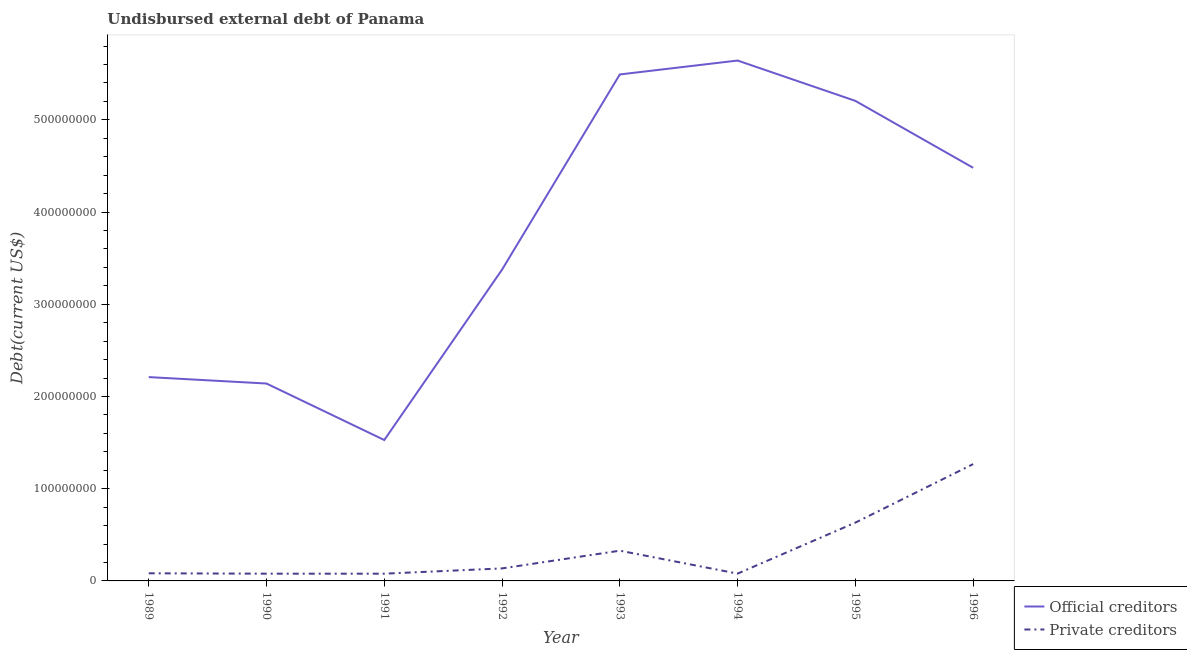What is the undisbursed external debt of private creditors in 1995?
Ensure brevity in your answer.  6.32e+07. Across all years, what is the maximum undisbursed external debt of official creditors?
Offer a terse response. 5.64e+08. Across all years, what is the minimum undisbursed external debt of private creditors?
Provide a short and direct response. 7.85e+06. In which year was the undisbursed external debt of official creditors minimum?
Your answer should be very brief. 1991. What is the total undisbursed external debt of official creditors in the graph?
Give a very brief answer. 3.01e+09. What is the difference between the undisbursed external debt of official creditors in 1992 and that in 1996?
Keep it short and to the point. -1.10e+08. What is the difference between the undisbursed external debt of official creditors in 1996 and the undisbursed external debt of private creditors in 1992?
Your answer should be very brief. 4.34e+08. What is the average undisbursed external debt of official creditors per year?
Keep it short and to the point. 3.76e+08. In the year 1990, what is the difference between the undisbursed external debt of official creditors and undisbursed external debt of private creditors?
Your answer should be very brief. 2.06e+08. In how many years, is the undisbursed external debt of official creditors greater than 360000000 US$?
Offer a terse response. 4. What is the ratio of the undisbursed external debt of private creditors in 1993 to that in 1995?
Make the answer very short. 0.52. Is the undisbursed external debt of private creditors in 1992 less than that in 1994?
Make the answer very short. No. What is the difference between the highest and the second highest undisbursed external debt of official creditors?
Provide a short and direct response. 1.51e+07. What is the difference between the highest and the lowest undisbursed external debt of private creditors?
Your answer should be compact. 1.19e+08. Is the sum of the undisbursed external debt of official creditors in 1989 and 1991 greater than the maximum undisbursed external debt of private creditors across all years?
Your answer should be compact. Yes. Is the undisbursed external debt of private creditors strictly less than the undisbursed external debt of official creditors over the years?
Offer a very short reply. Yes. What is the difference between two consecutive major ticks on the Y-axis?
Your answer should be compact. 1.00e+08. Does the graph contain any zero values?
Offer a very short reply. No. Does the graph contain grids?
Provide a succinct answer. No. How are the legend labels stacked?
Provide a short and direct response. Vertical. What is the title of the graph?
Provide a short and direct response. Undisbursed external debt of Panama. Does "Under five" appear as one of the legend labels in the graph?
Provide a short and direct response. No. What is the label or title of the X-axis?
Ensure brevity in your answer.  Year. What is the label or title of the Y-axis?
Your response must be concise. Debt(current US$). What is the Debt(current US$) of Official creditors in 1989?
Ensure brevity in your answer.  2.21e+08. What is the Debt(current US$) of Private creditors in 1989?
Ensure brevity in your answer.  8.26e+06. What is the Debt(current US$) in Official creditors in 1990?
Provide a short and direct response. 2.14e+08. What is the Debt(current US$) of Private creditors in 1990?
Ensure brevity in your answer.  7.85e+06. What is the Debt(current US$) in Official creditors in 1991?
Keep it short and to the point. 1.53e+08. What is the Debt(current US$) in Private creditors in 1991?
Provide a short and direct response. 7.85e+06. What is the Debt(current US$) in Official creditors in 1992?
Make the answer very short. 3.38e+08. What is the Debt(current US$) in Private creditors in 1992?
Offer a very short reply. 1.36e+07. What is the Debt(current US$) in Official creditors in 1993?
Offer a very short reply. 5.49e+08. What is the Debt(current US$) of Private creditors in 1993?
Your answer should be very brief. 3.28e+07. What is the Debt(current US$) in Official creditors in 1994?
Your answer should be compact. 5.64e+08. What is the Debt(current US$) of Private creditors in 1994?
Make the answer very short. 7.92e+06. What is the Debt(current US$) in Official creditors in 1995?
Ensure brevity in your answer.  5.21e+08. What is the Debt(current US$) in Private creditors in 1995?
Give a very brief answer. 6.32e+07. What is the Debt(current US$) in Official creditors in 1996?
Give a very brief answer. 4.48e+08. What is the Debt(current US$) in Private creditors in 1996?
Your answer should be compact. 1.27e+08. Across all years, what is the maximum Debt(current US$) of Official creditors?
Ensure brevity in your answer.  5.64e+08. Across all years, what is the maximum Debt(current US$) in Private creditors?
Provide a succinct answer. 1.27e+08. Across all years, what is the minimum Debt(current US$) of Official creditors?
Provide a short and direct response. 1.53e+08. Across all years, what is the minimum Debt(current US$) of Private creditors?
Make the answer very short. 7.85e+06. What is the total Debt(current US$) in Official creditors in the graph?
Provide a succinct answer. 3.01e+09. What is the total Debt(current US$) in Private creditors in the graph?
Make the answer very short. 2.68e+08. What is the difference between the Debt(current US$) of Official creditors in 1989 and that in 1990?
Ensure brevity in your answer.  6.97e+06. What is the difference between the Debt(current US$) in Private creditors in 1989 and that in 1990?
Offer a very short reply. 4.11e+05. What is the difference between the Debt(current US$) of Official creditors in 1989 and that in 1991?
Your answer should be compact. 6.82e+07. What is the difference between the Debt(current US$) in Private creditors in 1989 and that in 1991?
Keep it short and to the point. 4.18e+05. What is the difference between the Debt(current US$) in Official creditors in 1989 and that in 1992?
Your answer should be very brief. -1.17e+08. What is the difference between the Debt(current US$) in Private creditors in 1989 and that in 1992?
Keep it short and to the point. -5.31e+06. What is the difference between the Debt(current US$) in Official creditors in 1989 and that in 1993?
Make the answer very short. -3.28e+08. What is the difference between the Debt(current US$) of Private creditors in 1989 and that in 1993?
Keep it short and to the point. -2.45e+07. What is the difference between the Debt(current US$) of Official creditors in 1989 and that in 1994?
Your response must be concise. -3.43e+08. What is the difference between the Debt(current US$) of Private creditors in 1989 and that in 1994?
Offer a terse response. 3.43e+05. What is the difference between the Debt(current US$) of Official creditors in 1989 and that in 1995?
Make the answer very short. -3.00e+08. What is the difference between the Debt(current US$) in Private creditors in 1989 and that in 1995?
Ensure brevity in your answer.  -5.50e+07. What is the difference between the Debt(current US$) of Official creditors in 1989 and that in 1996?
Your answer should be very brief. -2.27e+08. What is the difference between the Debt(current US$) in Private creditors in 1989 and that in 1996?
Your answer should be compact. -1.18e+08. What is the difference between the Debt(current US$) of Official creditors in 1990 and that in 1991?
Give a very brief answer. 6.13e+07. What is the difference between the Debt(current US$) in Private creditors in 1990 and that in 1991?
Your answer should be very brief. 7000. What is the difference between the Debt(current US$) of Official creditors in 1990 and that in 1992?
Your answer should be compact. -1.23e+08. What is the difference between the Debt(current US$) of Private creditors in 1990 and that in 1992?
Your response must be concise. -5.72e+06. What is the difference between the Debt(current US$) of Official creditors in 1990 and that in 1993?
Ensure brevity in your answer.  -3.35e+08. What is the difference between the Debt(current US$) in Private creditors in 1990 and that in 1993?
Keep it short and to the point. -2.49e+07. What is the difference between the Debt(current US$) in Official creditors in 1990 and that in 1994?
Provide a short and direct response. -3.50e+08. What is the difference between the Debt(current US$) of Private creditors in 1990 and that in 1994?
Offer a terse response. -6.80e+04. What is the difference between the Debt(current US$) in Official creditors in 1990 and that in 1995?
Your response must be concise. -3.06e+08. What is the difference between the Debt(current US$) of Private creditors in 1990 and that in 1995?
Provide a short and direct response. -5.54e+07. What is the difference between the Debt(current US$) of Official creditors in 1990 and that in 1996?
Ensure brevity in your answer.  -2.34e+08. What is the difference between the Debt(current US$) of Private creditors in 1990 and that in 1996?
Ensure brevity in your answer.  -1.19e+08. What is the difference between the Debt(current US$) of Official creditors in 1991 and that in 1992?
Offer a terse response. -1.85e+08. What is the difference between the Debt(current US$) in Private creditors in 1991 and that in 1992?
Give a very brief answer. -5.73e+06. What is the difference between the Debt(current US$) in Official creditors in 1991 and that in 1993?
Give a very brief answer. -3.96e+08. What is the difference between the Debt(current US$) of Private creditors in 1991 and that in 1993?
Your response must be concise. -2.49e+07. What is the difference between the Debt(current US$) of Official creditors in 1991 and that in 1994?
Make the answer very short. -4.12e+08. What is the difference between the Debt(current US$) of Private creditors in 1991 and that in 1994?
Offer a terse response. -7.50e+04. What is the difference between the Debt(current US$) in Official creditors in 1991 and that in 1995?
Make the answer very short. -3.68e+08. What is the difference between the Debt(current US$) of Private creditors in 1991 and that in 1995?
Offer a terse response. -5.54e+07. What is the difference between the Debt(current US$) of Official creditors in 1991 and that in 1996?
Your answer should be compact. -2.95e+08. What is the difference between the Debt(current US$) of Private creditors in 1991 and that in 1996?
Provide a short and direct response. -1.19e+08. What is the difference between the Debt(current US$) in Official creditors in 1992 and that in 1993?
Your response must be concise. -2.12e+08. What is the difference between the Debt(current US$) in Private creditors in 1992 and that in 1993?
Provide a succinct answer. -1.92e+07. What is the difference between the Debt(current US$) in Official creditors in 1992 and that in 1994?
Your answer should be very brief. -2.27e+08. What is the difference between the Debt(current US$) in Private creditors in 1992 and that in 1994?
Your answer should be compact. 5.66e+06. What is the difference between the Debt(current US$) in Official creditors in 1992 and that in 1995?
Your response must be concise. -1.83e+08. What is the difference between the Debt(current US$) of Private creditors in 1992 and that in 1995?
Make the answer very short. -4.96e+07. What is the difference between the Debt(current US$) of Official creditors in 1992 and that in 1996?
Keep it short and to the point. -1.10e+08. What is the difference between the Debt(current US$) in Private creditors in 1992 and that in 1996?
Offer a very short reply. -1.13e+08. What is the difference between the Debt(current US$) of Official creditors in 1993 and that in 1994?
Keep it short and to the point. -1.51e+07. What is the difference between the Debt(current US$) in Private creditors in 1993 and that in 1994?
Your answer should be very brief. 2.49e+07. What is the difference between the Debt(current US$) in Official creditors in 1993 and that in 1995?
Provide a short and direct response. 2.87e+07. What is the difference between the Debt(current US$) in Private creditors in 1993 and that in 1995?
Keep it short and to the point. -3.04e+07. What is the difference between the Debt(current US$) of Official creditors in 1993 and that in 1996?
Your response must be concise. 1.01e+08. What is the difference between the Debt(current US$) of Private creditors in 1993 and that in 1996?
Provide a short and direct response. -9.39e+07. What is the difference between the Debt(current US$) in Official creditors in 1994 and that in 1995?
Provide a short and direct response. 4.38e+07. What is the difference between the Debt(current US$) in Private creditors in 1994 and that in 1995?
Offer a very short reply. -5.53e+07. What is the difference between the Debt(current US$) of Official creditors in 1994 and that in 1996?
Ensure brevity in your answer.  1.16e+08. What is the difference between the Debt(current US$) of Private creditors in 1994 and that in 1996?
Give a very brief answer. -1.19e+08. What is the difference between the Debt(current US$) of Official creditors in 1995 and that in 1996?
Provide a short and direct response. 7.26e+07. What is the difference between the Debt(current US$) in Private creditors in 1995 and that in 1996?
Your response must be concise. -6.35e+07. What is the difference between the Debt(current US$) in Official creditors in 1989 and the Debt(current US$) in Private creditors in 1990?
Keep it short and to the point. 2.13e+08. What is the difference between the Debt(current US$) of Official creditors in 1989 and the Debt(current US$) of Private creditors in 1991?
Keep it short and to the point. 2.13e+08. What is the difference between the Debt(current US$) of Official creditors in 1989 and the Debt(current US$) of Private creditors in 1992?
Your answer should be very brief. 2.07e+08. What is the difference between the Debt(current US$) in Official creditors in 1989 and the Debt(current US$) in Private creditors in 1993?
Offer a very short reply. 1.88e+08. What is the difference between the Debt(current US$) in Official creditors in 1989 and the Debt(current US$) in Private creditors in 1994?
Offer a very short reply. 2.13e+08. What is the difference between the Debt(current US$) of Official creditors in 1989 and the Debt(current US$) of Private creditors in 1995?
Your answer should be very brief. 1.58e+08. What is the difference between the Debt(current US$) in Official creditors in 1989 and the Debt(current US$) in Private creditors in 1996?
Your response must be concise. 9.43e+07. What is the difference between the Debt(current US$) of Official creditors in 1990 and the Debt(current US$) of Private creditors in 1991?
Keep it short and to the point. 2.06e+08. What is the difference between the Debt(current US$) of Official creditors in 1990 and the Debt(current US$) of Private creditors in 1992?
Provide a succinct answer. 2.00e+08. What is the difference between the Debt(current US$) of Official creditors in 1990 and the Debt(current US$) of Private creditors in 1993?
Ensure brevity in your answer.  1.81e+08. What is the difference between the Debt(current US$) in Official creditors in 1990 and the Debt(current US$) in Private creditors in 1994?
Give a very brief answer. 2.06e+08. What is the difference between the Debt(current US$) of Official creditors in 1990 and the Debt(current US$) of Private creditors in 1995?
Give a very brief answer. 1.51e+08. What is the difference between the Debt(current US$) in Official creditors in 1990 and the Debt(current US$) in Private creditors in 1996?
Offer a terse response. 8.74e+07. What is the difference between the Debt(current US$) of Official creditors in 1991 and the Debt(current US$) of Private creditors in 1992?
Provide a short and direct response. 1.39e+08. What is the difference between the Debt(current US$) of Official creditors in 1991 and the Debt(current US$) of Private creditors in 1993?
Keep it short and to the point. 1.20e+08. What is the difference between the Debt(current US$) of Official creditors in 1991 and the Debt(current US$) of Private creditors in 1994?
Provide a short and direct response. 1.45e+08. What is the difference between the Debt(current US$) of Official creditors in 1991 and the Debt(current US$) of Private creditors in 1995?
Make the answer very short. 8.96e+07. What is the difference between the Debt(current US$) in Official creditors in 1991 and the Debt(current US$) in Private creditors in 1996?
Ensure brevity in your answer.  2.61e+07. What is the difference between the Debt(current US$) of Official creditors in 1992 and the Debt(current US$) of Private creditors in 1993?
Provide a short and direct response. 3.05e+08. What is the difference between the Debt(current US$) of Official creditors in 1992 and the Debt(current US$) of Private creditors in 1994?
Your answer should be compact. 3.30e+08. What is the difference between the Debt(current US$) of Official creditors in 1992 and the Debt(current US$) of Private creditors in 1995?
Ensure brevity in your answer.  2.74e+08. What is the difference between the Debt(current US$) in Official creditors in 1992 and the Debt(current US$) in Private creditors in 1996?
Provide a succinct answer. 2.11e+08. What is the difference between the Debt(current US$) of Official creditors in 1993 and the Debt(current US$) of Private creditors in 1994?
Your answer should be very brief. 5.41e+08. What is the difference between the Debt(current US$) in Official creditors in 1993 and the Debt(current US$) in Private creditors in 1995?
Make the answer very short. 4.86e+08. What is the difference between the Debt(current US$) in Official creditors in 1993 and the Debt(current US$) in Private creditors in 1996?
Your response must be concise. 4.23e+08. What is the difference between the Debt(current US$) in Official creditors in 1994 and the Debt(current US$) in Private creditors in 1995?
Ensure brevity in your answer.  5.01e+08. What is the difference between the Debt(current US$) in Official creditors in 1994 and the Debt(current US$) in Private creditors in 1996?
Offer a very short reply. 4.38e+08. What is the difference between the Debt(current US$) in Official creditors in 1995 and the Debt(current US$) in Private creditors in 1996?
Offer a terse response. 3.94e+08. What is the average Debt(current US$) of Official creditors per year?
Make the answer very short. 3.76e+08. What is the average Debt(current US$) in Private creditors per year?
Your response must be concise. 3.35e+07. In the year 1989, what is the difference between the Debt(current US$) of Official creditors and Debt(current US$) of Private creditors?
Offer a terse response. 2.13e+08. In the year 1990, what is the difference between the Debt(current US$) in Official creditors and Debt(current US$) in Private creditors?
Offer a very short reply. 2.06e+08. In the year 1991, what is the difference between the Debt(current US$) of Official creditors and Debt(current US$) of Private creditors?
Provide a succinct answer. 1.45e+08. In the year 1992, what is the difference between the Debt(current US$) of Official creditors and Debt(current US$) of Private creditors?
Ensure brevity in your answer.  3.24e+08. In the year 1993, what is the difference between the Debt(current US$) in Official creditors and Debt(current US$) in Private creditors?
Your answer should be very brief. 5.16e+08. In the year 1994, what is the difference between the Debt(current US$) of Official creditors and Debt(current US$) of Private creditors?
Provide a succinct answer. 5.56e+08. In the year 1995, what is the difference between the Debt(current US$) of Official creditors and Debt(current US$) of Private creditors?
Your answer should be compact. 4.57e+08. In the year 1996, what is the difference between the Debt(current US$) in Official creditors and Debt(current US$) in Private creditors?
Your answer should be very brief. 3.21e+08. What is the ratio of the Debt(current US$) of Official creditors in 1989 to that in 1990?
Your answer should be very brief. 1.03. What is the ratio of the Debt(current US$) in Private creditors in 1989 to that in 1990?
Your answer should be compact. 1.05. What is the ratio of the Debt(current US$) of Official creditors in 1989 to that in 1991?
Give a very brief answer. 1.45. What is the ratio of the Debt(current US$) in Private creditors in 1989 to that in 1991?
Make the answer very short. 1.05. What is the ratio of the Debt(current US$) of Official creditors in 1989 to that in 1992?
Keep it short and to the point. 0.65. What is the ratio of the Debt(current US$) of Private creditors in 1989 to that in 1992?
Keep it short and to the point. 0.61. What is the ratio of the Debt(current US$) of Official creditors in 1989 to that in 1993?
Offer a terse response. 0.4. What is the ratio of the Debt(current US$) of Private creditors in 1989 to that in 1993?
Keep it short and to the point. 0.25. What is the ratio of the Debt(current US$) of Official creditors in 1989 to that in 1994?
Give a very brief answer. 0.39. What is the ratio of the Debt(current US$) in Private creditors in 1989 to that in 1994?
Your answer should be compact. 1.04. What is the ratio of the Debt(current US$) of Official creditors in 1989 to that in 1995?
Offer a terse response. 0.42. What is the ratio of the Debt(current US$) of Private creditors in 1989 to that in 1995?
Offer a very short reply. 0.13. What is the ratio of the Debt(current US$) of Official creditors in 1989 to that in 1996?
Give a very brief answer. 0.49. What is the ratio of the Debt(current US$) in Private creditors in 1989 to that in 1996?
Your answer should be very brief. 0.07. What is the ratio of the Debt(current US$) in Official creditors in 1990 to that in 1991?
Your answer should be very brief. 1.4. What is the ratio of the Debt(current US$) of Official creditors in 1990 to that in 1992?
Offer a terse response. 0.63. What is the ratio of the Debt(current US$) of Private creditors in 1990 to that in 1992?
Ensure brevity in your answer.  0.58. What is the ratio of the Debt(current US$) of Official creditors in 1990 to that in 1993?
Make the answer very short. 0.39. What is the ratio of the Debt(current US$) of Private creditors in 1990 to that in 1993?
Ensure brevity in your answer.  0.24. What is the ratio of the Debt(current US$) in Official creditors in 1990 to that in 1994?
Make the answer very short. 0.38. What is the ratio of the Debt(current US$) of Official creditors in 1990 to that in 1995?
Give a very brief answer. 0.41. What is the ratio of the Debt(current US$) of Private creditors in 1990 to that in 1995?
Your answer should be very brief. 0.12. What is the ratio of the Debt(current US$) of Official creditors in 1990 to that in 1996?
Give a very brief answer. 0.48. What is the ratio of the Debt(current US$) of Private creditors in 1990 to that in 1996?
Give a very brief answer. 0.06. What is the ratio of the Debt(current US$) of Official creditors in 1991 to that in 1992?
Provide a succinct answer. 0.45. What is the ratio of the Debt(current US$) in Private creditors in 1991 to that in 1992?
Provide a succinct answer. 0.58. What is the ratio of the Debt(current US$) of Official creditors in 1991 to that in 1993?
Your response must be concise. 0.28. What is the ratio of the Debt(current US$) in Private creditors in 1991 to that in 1993?
Give a very brief answer. 0.24. What is the ratio of the Debt(current US$) of Official creditors in 1991 to that in 1994?
Give a very brief answer. 0.27. What is the ratio of the Debt(current US$) in Official creditors in 1991 to that in 1995?
Offer a terse response. 0.29. What is the ratio of the Debt(current US$) in Private creditors in 1991 to that in 1995?
Your answer should be compact. 0.12. What is the ratio of the Debt(current US$) in Official creditors in 1991 to that in 1996?
Keep it short and to the point. 0.34. What is the ratio of the Debt(current US$) of Private creditors in 1991 to that in 1996?
Provide a short and direct response. 0.06. What is the ratio of the Debt(current US$) in Official creditors in 1992 to that in 1993?
Ensure brevity in your answer.  0.61. What is the ratio of the Debt(current US$) in Private creditors in 1992 to that in 1993?
Your answer should be compact. 0.41. What is the ratio of the Debt(current US$) of Official creditors in 1992 to that in 1994?
Offer a terse response. 0.6. What is the ratio of the Debt(current US$) in Private creditors in 1992 to that in 1994?
Give a very brief answer. 1.71. What is the ratio of the Debt(current US$) of Official creditors in 1992 to that in 1995?
Ensure brevity in your answer.  0.65. What is the ratio of the Debt(current US$) of Private creditors in 1992 to that in 1995?
Provide a succinct answer. 0.21. What is the ratio of the Debt(current US$) of Official creditors in 1992 to that in 1996?
Provide a short and direct response. 0.75. What is the ratio of the Debt(current US$) of Private creditors in 1992 to that in 1996?
Your answer should be compact. 0.11. What is the ratio of the Debt(current US$) of Official creditors in 1993 to that in 1994?
Your response must be concise. 0.97. What is the ratio of the Debt(current US$) in Private creditors in 1993 to that in 1994?
Keep it short and to the point. 4.14. What is the ratio of the Debt(current US$) of Official creditors in 1993 to that in 1995?
Offer a terse response. 1.06. What is the ratio of the Debt(current US$) of Private creditors in 1993 to that in 1995?
Keep it short and to the point. 0.52. What is the ratio of the Debt(current US$) of Official creditors in 1993 to that in 1996?
Offer a terse response. 1.23. What is the ratio of the Debt(current US$) of Private creditors in 1993 to that in 1996?
Provide a short and direct response. 0.26. What is the ratio of the Debt(current US$) of Official creditors in 1994 to that in 1995?
Provide a succinct answer. 1.08. What is the ratio of the Debt(current US$) of Private creditors in 1994 to that in 1995?
Your response must be concise. 0.13. What is the ratio of the Debt(current US$) in Official creditors in 1994 to that in 1996?
Keep it short and to the point. 1.26. What is the ratio of the Debt(current US$) of Private creditors in 1994 to that in 1996?
Ensure brevity in your answer.  0.06. What is the ratio of the Debt(current US$) of Official creditors in 1995 to that in 1996?
Keep it short and to the point. 1.16. What is the ratio of the Debt(current US$) of Private creditors in 1995 to that in 1996?
Give a very brief answer. 0.5. What is the difference between the highest and the second highest Debt(current US$) of Official creditors?
Keep it short and to the point. 1.51e+07. What is the difference between the highest and the second highest Debt(current US$) of Private creditors?
Ensure brevity in your answer.  6.35e+07. What is the difference between the highest and the lowest Debt(current US$) in Official creditors?
Your response must be concise. 4.12e+08. What is the difference between the highest and the lowest Debt(current US$) of Private creditors?
Your answer should be compact. 1.19e+08. 